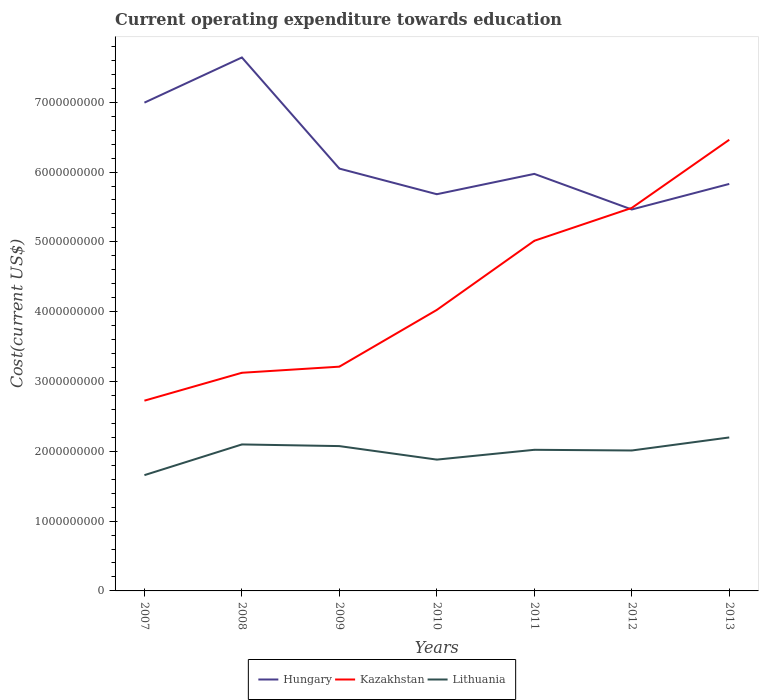How many different coloured lines are there?
Give a very brief answer. 3. Does the line corresponding to Kazakhstan intersect with the line corresponding to Lithuania?
Make the answer very short. No. Across all years, what is the maximum expenditure towards education in Lithuania?
Offer a terse response. 1.66e+09. In which year was the expenditure towards education in Hungary maximum?
Keep it short and to the point. 2012. What is the total expenditure towards education in Kazakhstan in the graph?
Offer a terse response. -9.00e+08. What is the difference between the highest and the second highest expenditure towards education in Lithuania?
Offer a terse response. 5.40e+08. How many lines are there?
Give a very brief answer. 3. How many years are there in the graph?
Your answer should be compact. 7. What is the difference between two consecutive major ticks on the Y-axis?
Give a very brief answer. 1.00e+09. Does the graph contain grids?
Provide a short and direct response. No. Where does the legend appear in the graph?
Offer a terse response. Bottom center. How many legend labels are there?
Provide a succinct answer. 3. What is the title of the graph?
Your response must be concise. Current operating expenditure towards education. What is the label or title of the X-axis?
Keep it short and to the point. Years. What is the label or title of the Y-axis?
Ensure brevity in your answer.  Cost(current US$). What is the Cost(current US$) of Hungary in 2007?
Your answer should be very brief. 6.99e+09. What is the Cost(current US$) of Kazakhstan in 2007?
Give a very brief answer. 2.73e+09. What is the Cost(current US$) in Lithuania in 2007?
Offer a terse response. 1.66e+09. What is the Cost(current US$) of Hungary in 2008?
Keep it short and to the point. 7.64e+09. What is the Cost(current US$) in Kazakhstan in 2008?
Your response must be concise. 3.12e+09. What is the Cost(current US$) of Lithuania in 2008?
Your answer should be compact. 2.10e+09. What is the Cost(current US$) of Hungary in 2009?
Offer a terse response. 6.05e+09. What is the Cost(current US$) in Kazakhstan in 2009?
Offer a terse response. 3.21e+09. What is the Cost(current US$) in Lithuania in 2009?
Make the answer very short. 2.07e+09. What is the Cost(current US$) in Hungary in 2010?
Offer a very short reply. 5.68e+09. What is the Cost(current US$) of Kazakhstan in 2010?
Your answer should be very brief. 4.03e+09. What is the Cost(current US$) of Lithuania in 2010?
Your answer should be compact. 1.88e+09. What is the Cost(current US$) of Hungary in 2011?
Provide a short and direct response. 5.97e+09. What is the Cost(current US$) in Kazakhstan in 2011?
Offer a very short reply. 5.02e+09. What is the Cost(current US$) in Lithuania in 2011?
Provide a succinct answer. 2.02e+09. What is the Cost(current US$) in Hungary in 2012?
Offer a very short reply. 5.46e+09. What is the Cost(current US$) in Kazakhstan in 2012?
Offer a terse response. 5.49e+09. What is the Cost(current US$) in Lithuania in 2012?
Provide a short and direct response. 2.01e+09. What is the Cost(current US$) of Hungary in 2013?
Keep it short and to the point. 5.83e+09. What is the Cost(current US$) of Kazakhstan in 2013?
Give a very brief answer. 6.46e+09. What is the Cost(current US$) of Lithuania in 2013?
Provide a short and direct response. 2.20e+09. Across all years, what is the maximum Cost(current US$) of Hungary?
Provide a short and direct response. 7.64e+09. Across all years, what is the maximum Cost(current US$) in Kazakhstan?
Provide a succinct answer. 6.46e+09. Across all years, what is the maximum Cost(current US$) of Lithuania?
Provide a short and direct response. 2.20e+09. Across all years, what is the minimum Cost(current US$) in Hungary?
Offer a very short reply. 5.46e+09. Across all years, what is the minimum Cost(current US$) in Kazakhstan?
Provide a short and direct response. 2.73e+09. Across all years, what is the minimum Cost(current US$) in Lithuania?
Your answer should be very brief. 1.66e+09. What is the total Cost(current US$) in Hungary in the graph?
Offer a terse response. 4.36e+1. What is the total Cost(current US$) of Kazakhstan in the graph?
Keep it short and to the point. 3.01e+1. What is the total Cost(current US$) of Lithuania in the graph?
Provide a short and direct response. 1.39e+1. What is the difference between the Cost(current US$) of Hungary in 2007 and that in 2008?
Your answer should be very brief. -6.47e+08. What is the difference between the Cost(current US$) of Kazakhstan in 2007 and that in 2008?
Provide a succinct answer. -4.00e+08. What is the difference between the Cost(current US$) in Lithuania in 2007 and that in 2008?
Offer a terse response. -4.40e+08. What is the difference between the Cost(current US$) in Hungary in 2007 and that in 2009?
Your answer should be very brief. 9.45e+08. What is the difference between the Cost(current US$) in Kazakhstan in 2007 and that in 2009?
Provide a short and direct response. -4.87e+08. What is the difference between the Cost(current US$) of Lithuania in 2007 and that in 2009?
Ensure brevity in your answer.  -4.16e+08. What is the difference between the Cost(current US$) of Hungary in 2007 and that in 2010?
Provide a short and direct response. 1.31e+09. What is the difference between the Cost(current US$) of Kazakhstan in 2007 and that in 2010?
Ensure brevity in your answer.  -1.30e+09. What is the difference between the Cost(current US$) of Lithuania in 2007 and that in 2010?
Offer a very short reply. -2.22e+08. What is the difference between the Cost(current US$) of Hungary in 2007 and that in 2011?
Provide a short and direct response. 1.02e+09. What is the difference between the Cost(current US$) of Kazakhstan in 2007 and that in 2011?
Ensure brevity in your answer.  -2.29e+09. What is the difference between the Cost(current US$) of Lithuania in 2007 and that in 2011?
Your answer should be very brief. -3.63e+08. What is the difference between the Cost(current US$) of Hungary in 2007 and that in 2012?
Make the answer very short. 1.53e+09. What is the difference between the Cost(current US$) in Kazakhstan in 2007 and that in 2012?
Provide a short and direct response. -2.76e+09. What is the difference between the Cost(current US$) of Lithuania in 2007 and that in 2012?
Provide a short and direct response. -3.53e+08. What is the difference between the Cost(current US$) in Hungary in 2007 and that in 2013?
Your answer should be compact. 1.16e+09. What is the difference between the Cost(current US$) of Kazakhstan in 2007 and that in 2013?
Ensure brevity in your answer.  -3.74e+09. What is the difference between the Cost(current US$) of Lithuania in 2007 and that in 2013?
Provide a succinct answer. -5.40e+08. What is the difference between the Cost(current US$) of Hungary in 2008 and that in 2009?
Keep it short and to the point. 1.59e+09. What is the difference between the Cost(current US$) of Kazakhstan in 2008 and that in 2009?
Your answer should be compact. -8.75e+07. What is the difference between the Cost(current US$) in Lithuania in 2008 and that in 2009?
Your answer should be compact. 2.38e+07. What is the difference between the Cost(current US$) in Hungary in 2008 and that in 2010?
Offer a very short reply. 1.96e+09. What is the difference between the Cost(current US$) of Kazakhstan in 2008 and that in 2010?
Ensure brevity in your answer.  -9.00e+08. What is the difference between the Cost(current US$) in Lithuania in 2008 and that in 2010?
Make the answer very short. 2.17e+08. What is the difference between the Cost(current US$) of Hungary in 2008 and that in 2011?
Provide a succinct answer. 1.67e+09. What is the difference between the Cost(current US$) of Kazakhstan in 2008 and that in 2011?
Provide a short and direct response. -1.89e+09. What is the difference between the Cost(current US$) in Lithuania in 2008 and that in 2011?
Offer a terse response. 7.68e+07. What is the difference between the Cost(current US$) in Hungary in 2008 and that in 2012?
Offer a terse response. 2.18e+09. What is the difference between the Cost(current US$) of Kazakhstan in 2008 and that in 2012?
Your response must be concise. -2.36e+09. What is the difference between the Cost(current US$) in Lithuania in 2008 and that in 2012?
Keep it short and to the point. 8.66e+07. What is the difference between the Cost(current US$) of Hungary in 2008 and that in 2013?
Give a very brief answer. 1.81e+09. What is the difference between the Cost(current US$) of Kazakhstan in 2008 and that in 2013?
Ensure brevity in your answer.  -3.34e+09. What is the difference between the Cost(current US$) in Lithuania in 2008 and that in 2013?
Offer a very short reply. -1.00e+08. What is the difference between the Cost(current US$) of Hungary in 2009 and that in 2010?
Your answer should be very brief. 3.67e+08. What is the difference between the Cost(current US$) in Kazakhstan in 2009 and that in 2010?
Your answer should be compact. -8.13e+08. What is the difference between the Cost(current US$) of Lithuania in 2009 and that in 2010?
Provide a short and direct response. 1.94e+08. What is the difference between the Cost(current US$) in Hungary in 2009 and that in 2011?
Offer a terse response. 7.58e+07. What is the difference between the Cost(current US$) of Kazakhstan in 2009 and that in 2011?
Your answer should be compact. -1.80e+09. What is the difference between the Cost(current US$) in Lithuania in 2009 and that in 2011?
Provide a short and direct response. 5.31e+07. What is the difference between the Cost(current US$) of Hungary in 2009 and that in 2012?
Keep it short and to the point. 5.86e+08. What is the difference between the Cost(current US$) of Kazakhstan in 2009 and that in 2012?
Offer a terse response. -2.27e+09. What is the difference between the Cost(current US$) in Lithuania in 2009 and that in 2012?
Your answer should be very brief. 6.28e+07. What is the difference between the Cost(current US$) of Hungary in 2009 and that in 2013?
Offer a terse response. 2.20e+08. What is the difference between the Cost(current US$) of Kazakhstan in 2009 and that in 2013?
Offer a terse response. -3.25e+09. What is the difference between the Cost(current US$) of Lithuania in 2009 and that in 2013?
Give a very brief answer. -1.24e+08. What is the difference between the Cost(current US$) in Hungary in 2010 and that in 2011?
Your response must be concise. -2.91e+08. What is the difference between the Cost(current US$) of Kazakhstan in 2010 and that in 2011?
Your response must be concise. -9.90e+08. What is the difference between the Cost(current US$) of Lithuania in 2010 and that in 2011?
Ensure brevity in your answer.  -1.40e+08. What is the difference between the Cost(current US$) of Hungary in 2010 and that in 2012?
Your answer should be compact. 2.19e+08. What is the difference between the Cost(current US$) in Kazakhstan in 2010 and that in 2012?
Offer a terse response. -1.46e+09. What is the difference between the Cost(current US$) of Lithuania in 2010 and that in 2012?
Give a very brief answer. -1.31e+08. What is the difference between the Cost(current US$) in Hungary in 2010 and that in 2013?
Your answer should be very brief. -1.47e+08. What is the difference between the Cost(current US$) of Kazakhstan in 2010 and that in 2013?
Ensure brevity in your answer.  -2.44e+09. What is the difference between the Cost(current US$) of Lithuania in 2010 and that in 2013?
Your answer should be very brief. -3.17e+08. What is the difference between the Cost(current US$) in Hungary in 2011 and that in 2012?
Your answer should be very brief. 5.10e+08. What is the difference between the Cost(current US$) in Kazakhstan in 2011 and that in 2012?
Provide a short and direct response. -4.71e+08. What is the difference between the Cost(current US$) in Lithuania in 2011 and that in 2012?
Keep it short and to the point. 9.74e+06. What is the difference between the Cost(current US$) in Hungary in 2011 and that in 2013?
Offer a very short reply. 1.44e+08. What is the difference between the Cost(current US$) in Kazakhstan in 2011 and that in 2013?
Make the answer very short. -1.45e+09. What is the difference between the Cost(current US$) in Lithuania in 2011 and that in 2013?
Offer a terse response. -1.77e+08. What is the difference between the Cost(current US$) of Hungary in 2012 and that in 2013?
Give a very brief answer. -3.66e+08. What is the difference between the Cost(current US$) of Kazakhstan in 2012 and that in 2013?
Keep it short and to the point. -9.76e+08. What is the difference between the Cost(current US$) in Lithuania in 2012 and that in 2013?
Keep it short and to the point. -1.87e+08. What is the difference between the Cost(current US$) in Hungary in 2007 and the Cost(current US$) in Kazakhstan in 2008?
Your response must be concise. 3.87e+09. What is the difference between the Cost(current US$) of Hungary in 2007 and the Cost(current US$) of Lithuania in 2008?
Your answer should be very brief. 4.90e+09. What is the difference between the Cost(current US$) in Kazakhstan in 2007 and the Cost(current US$) in Lithuania in 2008?
Keep it short and to the point. 6.27e+08. What is the difference between the Cost(current US$) in Hungary in 2007 and the Cost(current US$) in Kazakhstan in 2009?
Keep it short and to the point. 3.78e+09. What is the difference between the Cost(current US$) in Hungary in 2007 and the Cost(current US$) in Lithuania in 2009?
Provide a short and direct response. 4.92e+09. What is the difference between the Cost(current US$) in Kazakhstan in 2007 and the Cost(current US$) in Lithuania in 2009?
Provide a succinct answer. 6.51e+08. What is the difference between the Cost(current US$) in Hungary in 2007 and the Cost(current US$) in Kazakhstan in 2010?
Your response must be concise. 2.97e+09. What is the difference between the Cost(current US$) of Hungary in 2007 and the Cost(current US$) of Lithuania in 2010?
Offer a very short reply. 5.11e+09. What is the difference between the Cost(current US$) of Kazakhstan in 2007 and the Cost(current US$) of Lithuania in 2010?
Give a very brief answer. 8.44e+08. What is the difference between the Cost(current US$) in Hungary in 2007 and the Cost(current US$) in Kazakhstan in 2011?
Your answer should be compact. 1.98e+09. What is the difference between the Cost(current US$) of Hungary in 2007 and the Cost(current US$) of Lithuania in 2011?
Keep it short and to the point. 4.97e+09. What is the difference between the Cost(current US$) of Kazakhstan in 2007 and the Cost(current US$) of Lithuania in 2011?
Offer a terse response. 7.04e+08. What is the difference between the Cost(current US$) of Hungary in 2007 and the Cost(current US$) of Kazakhstan in 2012?
Provide a short and direct response. 1.51e+09. What is the difference between the Cost(current US$) of Hungary in 2007 and the Cost(current US$) of Lithuania in 2012?
Offer a very short reply. 4.98e+09. What is the difference between the Cost(current US$) in Kazakhstan in 2007 and the Cost(current US$) in Lithuania in 2012?
Your answer should be very brief. 7.14e+08. What is the difference between the Cost(current US$) of Hungary in 2007 and the Cost(current US$) of Kazakhstan in 2013?
Offer a very short reply. 5.32e+08. What is the difference between the Cost(current US$) in Hungary in 2007 and the Cost(current US$) in Lithuania in 2013?
Ensure brevity in your answer.  4.80e+09. What is the difference between the Cost(current US$) of Kazakhstan in 2007 and the Cost(current US$) of Lithuania in 2013?
Your answer should be very brief. 5.27e+08. What is the difference between the Cost(current US$) in Hungary in 2008 and the Cost(current US$) in Kazakhstan in 2009?
Give a very brief answer. 4.43e+09. What is the difference between the Cost(current US$) of Hungary in 2008 and the Cost(current US$) of Lithuania in 2009?
Ensure brevity in your answer.  5.57e+09. What is the difference between the Cost(current US$) of Kazakhstan in 2008 and the Cost(current US$) of Lithuania in 2009?
Ensure brevity in your answer.  1.05e+09. What is the difference between the Cost(current US$) in Hungary in 2008 and the Cost(current US$) in Kazakhstan in 2010?
Your answer should be compact. 3.62e+09. What is the difference between the Cost(current US$) in Hungary in 2008 and the Cost(current US$) in Lithuania in 2010?
Keep it short and to the point. 5.76e+09. What is the difference between the Cost(current US$) in Kazakhstan in 2008 and the Cost(current US$) in Lithuania in 2010?
Offer a very short reply. 1.24e+09. What is the difference between the Cost(current US$) in Hungary in 2008 and the Cost(current US$) in Kazakhstan in 2011?
Make the answer very short. 2.63e+09. What is the difference between the Cost(current US$) in Hungary in 2008 and the Cost(current US$) in Lithuania in 2011?
Offer a very short reply. 5.62e+09. What is the difference between the Cost(current US$) in Kazakhstan in 2008 and the Cost(current US$) in Lithuania in 2011?
Your answer should be very brief. 1.10e+09. What is the difference between the Cost(current US$) in Hungary in 2008 and the Cost(current US$) in Kazakhstan in 2012?
Your answer should be very brief. 2.16e+09. What is the difference between the Cost(current US$) of Hungary in 2008 and the Cost(current US$) of Lithuania in 2012?
Make the answer very short. 5.63e+09. What is the difference between the Cost(current US$) in Kazakhstan in 2008 and the Cost(current US$) in Lithuania in 2012?
Ensure brevity in your answer.  1.11e+09. What is the difference between the Cost(current US$) in Hungary in 2008 and the Cost(current US$) in Kazakhstan in 2013?
Your response must be concise. 1.18e+09. What is the difference between the Cost(current US$) in Hungary in 2008 and the Cost(current US$) in Lithuania in 2013?
Make the answer very short. 5.44e+09. What is the difference between the Cost(current US$) in Kazakhstan in 2008 and the Cost(current US$) in Lithuania in 2013?
Make the answer very short. 9.26e+08. What is the difference between the Cost(current US$) of Hungary in 2009 and the Cost(current US$) of Kazakhstan in 2010?
Offer a very short reply. 2.02e+09. What is the difference between the Cost(current US$) of Hungary in 2009 and the Cost(current US$) of Lithuania in 2010?
Offer a terse response. 4.17e+09. What is the difference between the Cost(current US$) in Kazakhstan in 2009 and the Cost(current US$) in Lithuania in 2010?
Provide a succinct answer. 1.33e+09. What is the difference between the Cost(current US$) of Hungary in 2009 and the Cost(current US$) of Kazakhstan in 2011?
Your answer should be compact. 1.03e+09. What is the difference between the Cost(current US$) of Hungary in 2009 and the Cost(current US$) of Lithuania in 2011?
Make the answer very short. 4.03e+09. What is the difference between the Cost(current US$) in Kazakhstan in 2009 and the Cost(current US$) in Lithuania in 2011?
Ensure brevity in your answer.  1.19e+09. What is the difference between the Cost(current US$) in Hungary in 2009 and the Cost(current US$) in Kazakhstan in 2012?
Make the answer very short. 5.63e+08. What is the difference between the Cost(current US$) in Hungary in 2009 and the Cost(current US$) in Lithuania in 2012?
Your response must be concise. 4.04e+09. What is the difference between the Cost(current US$) of Kazakhstan in 2009 and the Cost(current US$) of Lithuania in 2012?
Make the answer very short. 1.20e+09. What is the difference between the Cost(current US$) of Hungary in 2009 and the Cost(current US$) of Kazakhstan in 2013?
Your response must be concise. -4.13e+08. What is the difference between the Cost(current US$) of Hungary in 2009 and the Cost(current US$) of Lithuania in 2013?
Your response must be concise. 3.85e+09. What is the difference between the Cost(current US$) in Kazakhstan in 2009 and the Cost(current US$) in Lithuania in 2013?
Provide a short and direct response. 1.01e+09. What is the difference between the Cost(current US$) in Hungary in 2010 and the Cost(current US$) in Kazakhstan in 2011?
Give a very brief answer. 6.67e+08. What is the difference between the Cost(current US$) in Hungary in 2010 and the Cost(current US$) in Lithuania in 2011?
Provide a short and direct response. 3.66e+09. What is the difference between the Cost(current US$) in Kazakhstan in 2010 and the Cost(current US$) in Lithuania in 2011?
Ensure brevity in your answer.  2.00e+09. What is the difference between the Cost(current US$) of Hungary in 2010 and the Cost(current US$) of Kazakhstan in 2012?
Give a very brief answer. 1.96e+08. What is the difference between the Cost(current US$) of Hungary in 2010 and the Cost(current US$) of Lithuania in 2012?
Your answer should be very brief. 3.67e+09. What is the difference between the Cost(current US$) in Kazakhstan in 2010 and the Cost(current US$) in Lithuania in 2012?
Give a very brief answer. 2.01e+09. What is the difference between the Cost(current US$) of Hungary in 2010 and the Cost(current US$) of Kazakhstan in 2013?
Your response must be concise. -7.80e+08. What is the difference between the Cost(current US$) of Hungary in 2010 and the Cost(current US$) of Lithuania in 2013?
Offer a terse response. 3.48e+09. What is the difference between the Cost(current US$) in Kazakhstan in 2010 and the Cost(current US$) in Lithuania in 2013?
Provide a succinct answer. 1.83e+09. What is the difference between the Cost(current US$) of Hungary in 2011 and the Cost(current US$) of Kazakhstan in 2012?
Your response must be concise. 4.87e+08. What is the difference between the Cost(current US$) of Hungary in 2011 and the Cost(current US$) of Lithuania in 2012?
Offer a very short reply. 3.96e+09. What is the difference between the Cost(current US$) of Kazakhstan in 2011 and the Cost(current US$) of Lithuania in 2012?
Your answer should be compact. 3.00e+09. What is the difference between the Cost(current US$) of Hungary in 2011 and the Cost(current US$) of Kazakhstan in 2013?
Your response must be concise. -4.89e+08. What is the difference between the Cost(current US$) of Hungary in 2011 and the Cost(current US$) of Lithuania in 2013?
Provide a short and direct response. 3.78e+09. What is the difference between the Cost(current US$) of Kazakhstan in 2011 and the Cost(current US$) of Lithuania in 2013?
Provide a short and direct response. 2.82e+09. What is the difference between the Cost(current US$) in Hungary in 2012 and the Cost(current US$) in Kazakhstan in 2013?
Your answer should be compact. -9.99e+08. What is the difference between the Cost(current US$) in Hungary in 2012 and the Cost(current US$) in Lithuania in 2013?
Give a very brief answer. 3.27e+09. What is the difference between the Cost(current US$) in Kazakhstan in 2012 and the Cost(current US$) in Lithuania in 2013?
Your answer should be compact. 3.29e+09. What is the average Cost(current US$) in Hungary per year?
Offer a very short reply. 6.23e+09. What is the average Cost(current US$) in Kazakhstan per year?
Your response must be concise. 4.29e+09. What is the average Cost(current US$) of Lithuania per year?
Keep it short and to the point. 1.99e+09. In the year 2007, what is the difference between the Cost(current US$) of Hungary and Cost(current US$) of Kazakhstan?
Provide a short and direct response. 4.27e+09. In the year 2007, what is the difference between the Cost(current US$) in Hungary and Cost(current US$) in Lithuania?
Offer a terse response. 5.34e+09. In the year 2007, what is the difference between the Cost(current US$) in Kazakhstan and Cost(current US$) in Lithuania?
Ensure brevity in your answer.  1.07e+09. In the year 2008, what is the difference between the Cost(current US$) of Hungary and Cost(current US$) of Kazakhstan?
Your response must be concise. 4.52e+09. In the year 2008, what is the difference between the Cost(current US$) in Hungary and Cost(current US$) in Lithuania?
Keep it short and to the point. 5.54e+09. In the year 2008, what is the difference between the Cost(current US$) of Kazakhstan and Cost(current US$) of Lithuania?
Ensure brevity in your answer.  1.03e+09. In the year 2009, what is the difference between the Cost(current US$) of Hungary and Cost(current US$) of Kazakhstan?
Keep it short and to the point. 2.84e+09. In the year 2009, what is the difference between the Cost(current US$) in Hungary and Cost(current US$) in Lithuania?
Your answer should be very brief. 3.98e+09. In the year 2009, what is the difference between the Cost(current US$) in Kazakhstan and Cost(current US$) in Lithuania?
Offer a terse response. 1.14e+09. In the year 2010, what is the difference between the Cost(current US$) of Hungary and Cost(current US$) of Kazakhstan?
Your answer should be compact. 1.66e+09. In the year 2010, what is the difference between the Cost(current US$) in Hungary and Cost(current US$) in Lithuania?
Provide a succinct answer. 3.80e+09. In the year 2010, what is the difference between the Cost(current US$) of Kazakhstan and Cost(current US$) of Lithuania?
Make the answer very short. 2.14e+09. In the year 2011, what is the difference between the Cost(current US$) in Hungary and Cost(current US$) in Kazakhstan?
Your response must be concise. 9.58e+08. In the year 2011, what is the difference between the Cost(current US$) of Hungary and Cost(current US$) of Lithuania?
Offer a terse response. 3.95e+09. In the year 2011, what is the difference between the Cost(current US$) in Kazakhstan and Cost(current US$) in Lithuania?
Offer a very short reply. 2.99e+09. In the year 2012, what is the difference between the Cost(current US$) in Hungary and Cost(current US$) in Kazakhstan?
Keep it short and to the point. -2.25e+07. In the year 2012, what is the difference between the Cost(current US$) in Hungary and Cost(current US$) in Lithuania?
Give a very brief answer. 3.45e+09. In the year 2012, what is the difference between the Cost(current US$) of Kazakhstan and Cost(current US$) of Lithuania?
Your answer should be very brief. 3.47e+09. In the year 2013, what is the difference between the Cost(current US$) in Hungary and Cost(current US$) in Kazakhstan?
Your answer should be very brief. -6.33e+08. In the year 2013, what is the difference between the Cost(current US$) of Hungary and Cost(current US$) of Lithuania?
Provide a succinct answer. 3.63e+09. In the year 2013, what is the difference between the Cost(current US$) in Kazakhstan and Cost(current US$) in Lithuania?
Keep it short and to the point. 4.26e+09. What is the ratio of the Cost(current US$) of Hungary in 2007 to that in 2008?
Your response must be concise. 0.92. What is the ratio of the Cost(current US$) of Kazakhstan in 2007 to that in 2008?
Give a very brief answer. 0.87. What is the ratio of the Cost(current US$) in Lithuania in 2007 to that in 2008?
Provide a succinct answer. 0.79. What is the ratio of the Cost(current US$) of Hungary in 2007 to that in 2009?
Make the answer very short. 1.16. What is the ratio of the Cost(current US$) in Kazakhstan in 2007 to that in 2009?
Ensure brevity in your answer.  0.85. What is the ratio of the Cost(current US$) in Lithuania in 2007 to that in 2009?
Provide a short and direct response. 0.8. What is the ratio of the Cost(current US$) of Hungary in 2007 to that in 2010?
Provide a short and direct response. 1.23. What is the ratio of the Cost(current US$) of Kazakhstan in 2007 to that in 2010?
Provide a succinct answer. 0.68. What is the ratio of the Cost(current US$) in Lithuania in 2007 to that in 2010?
Your response must be concise. 0.88. What is the ratio of the Cost(current US$) in Hungary in 2007 to that in 2011?
Provide a succinct answer. 1.17. What is the ratio of the Cost(current US$) of Kazakhstan in 2007 to that in 2011?
Your answer should be compact. 0.54. What is the ratio of the Cost(current US$) of Lithuania in 2007 to that in 2011?
Ensure brevity in your answer.  0.82. What is the ratio of the Cost(current US$) in Hungary in 2007 to that in 2012?
Give a very brief answer. 1.28. What is the ratio of the Cost(current US$) of Kazakhstan in 2007 to that in 2012?
Make the answer very short. 0.5. What is the ratio of the Cost(current US$) in Lithuania in 2007 to that in 2012?
Your answer should be compact. 0.82. What is the ratio of the Cost(current US$) of Hungary in 2007 to that in 2013?
Your answer should be compact. 1.2. What is the ratio of the Cost(current US$) of Kazakhstan in 2007 to that in 2013?
Your response must be concise. 0.42. What is the ratio of the Cost(current US$) of Lithuania in 2007 to that in 2013?
Provide a succinct answer. 0.75. What is the ratio of the Cost(current US$) of Hungary in 2008 to that in 2009?
Your response must be concise. 1.26. What is the ratio of the Cost(current US$) of Kazakhstan in 2008 to that in 2009?
Provide a succinct answer. 0.97. What is the ratio of the Cost(current US$) of Lithuania in 2008 to that in 2009?
Keep it short and to the point. 1.01. What is the ratio of the Cost(current US$) of Hungary in 2008 to that in 2010?
Give a very brief answer. 1.34. What is the ratio of the Cost(current US$) in Kazakhstan in 2008 to that in 2010?
Provide a short and direct response. 0.78. What is the ratio of the Cost(current US$) of Lithuania in 2008 to that in 2010?
Keep it short and to the point. 1.12. What is the ratio of the Cost(current US$) in Hungary in 2008 to that in 2011?
Provide a short and direct response. 1.28. What is the ratio of the Cost(current US$) of Kazakhstan in 2008 to that in 2011?
Make the answer very short. 0.62. What is the ratio of the Cost(current US$) of Lithuania in 2008 to that in 2011?
Offer a very short reply. 1.04. What is the ratio of the Cost(current US$) of Hungary in 2008 to that in 2012?
Offer a very short reply. 1.4. What is the ratio of the Cost(current US$) of Kazakhstan in 2008 to that in 2012?
Make the answer very short. 0.57. What is the ratio of the Cost(current US$) in Lithuania in 2008 to that in 2012?
Your response must be concise. 1.04. What is the ratio of the Cost(current US$) in Hungary in 2008 to that in 2013?
Provide a succinct answer. 1.31. What is the ratio of the Cost(current US$) in Kazakhstan in 2008 to that in 2013?
Provide a short and direct response. 0.48. What is the ratio of the Cost(current US$) in Lithuania in 2008 to that in 2013?
Ensure brevity in your answer.  0.95. What is the ratio of the Cost(current US$) of Hungary in 2009 to that in 2010?
Your answer should be very brief. 1.06. What is the ratio of the Cost(current US$) of Kazakhstan in 2009 to that in 2010?
Keep it short and to the point. 0.8. What is the ratio of the Cost(current US$) of Lithuania in 2009 to that in 2010?
Provide a short and direct response. 1.1. What is the ratio of the Cost(current US$) in Hungary in 2009 to that in 2011?
Make the answer very short. 1.01. What is the ratio of the Cost(current US$) in Kazakhstan in 2009 to that in 2011?
Provide a short and direct response. 0.64. What is the ratio of the Cost(current US$) of Lithuania in 2009 to that in 2011?
Ensure brevity in your answer.  1.03. What is the ratio of the Cost(current US$) in Hungary in 2009 to that in 2012?
Your answer should be compact. 1.11. What is the ratio of the Cost(current US$) in Kazakhstan in 2009 to that in 2012?
Keep it short and to the point. 0.59. What is the ratio of the Cost(current US$) in Lithuania in 2009 to that in 2012?
Give a very brief answer. 1.03. What is the ratio of the Cost(current US$) of Hungary in 2009 to that in 2013?
Keep it short and to the point. 1.04. What is the ratio of the Cost(current US$) of Kazakhstan in 2009 to that in 2013?
Your answer should be very brief. 0.5. What is the ratio of the Cost(current US$) in Lithuania in 2009 to that in 2013?
Your response must be concise. 0.94. What is the ratio of the Cost(current US$) in Hungary in 2010 to that in 2011?
Offer a terse response. 0.95. What is the ratio of the Cost(current US$) of Kazakhstan in 2010 to that in 2011?
Provide a short and direct response. 0.8. What is the ratio of the Cost(current US$) in Lithuania in 2010 to that in 2011?
Offer a very short reply. 0.93. What is the ratio of the Cost(current US$) of Hungary in 2010 to that in 2012?
Make the answer very short. 1.04. What is the ratio of the Cost(current US$) in Kazakhstan in 2010 to that in 2012?
Keep it short and to the point. 0.73. What is the ratio of the Cost(current US$) in Lithuania in 2010 to that in 2012?
Your response must be concise. 0.94. What is the ratio of the Cost(current US$) in Hungary in 2010 to that in 2013?
Make the answer very short. 0.97. What is the ratio of the Cost(current US$) of Kazakhstan in 2010 to that in 2013?
Offer a very short reply. 0.62. What is the ratio of the Cost(current US$) in Lithuania in 2010 to that in 2013?
Provide a short and direct response. 0.86. What is the ratio of the Cost(current US$) in Hungary in 2011 to that in 2012?
Your answer should be very brief. 1.09. What is the ratio of the Cost(current US$) in Kazakhstan in 2011 to that in 2012?
Your answer should be very brief. 0.91. What is the ratio of the Cost(current US$) of Hungary in 2011 to that in 2013?
Keep it short and to the point. 1.02. What is the ratio of the Cost(current US$) in Kazakhstan in 2011 to that in 2013?
Provide a short and direct response. 0.78. What is the ratio of the Cost(current US$) of Lithuania in 2011 to that in 2013?
Ensure brevity in your answer.  0.92. What is the ratio of the Cost(current US$) of Hungary in 2012 to that in 2013?
Offer a very short reply. 0.94. What is the ratio of the Cost(current US$) in Kazakhstan in 2012 to that in 2013?
Your answer should be compact. 0.85. What is the ratio of the Cost(current US$) in Lithuania in 2012 to that in 2013?
Offer a terse response. 0.92. What is the difference between the highest and the second highest Cost(current US$) of Hungary?
Provide a succinct answer. 6.47e+08. What is the difference between the highest and the second highest Cost(current US$) in Kazakhstan?
Offer a terse response. 9.76e+08. What is the difference between the highest and the second highest Cost(current US$) in Lithuania?
Offer a very short reply. 1.00e+08. What is the difference between the highest and the lowest Cost(current US$) in Hungary?
Provide a succinct answer. 2.18e+09. What is the difference between the highest and the lowest Cost(current US$) in Kazakhstan?
Ensure brevity in your answer.  3.74e+09. What is the difference between the highest and the lowest Cost(current US$) in Lithuania?
Provide a succinct answer. 5.40e+08. 